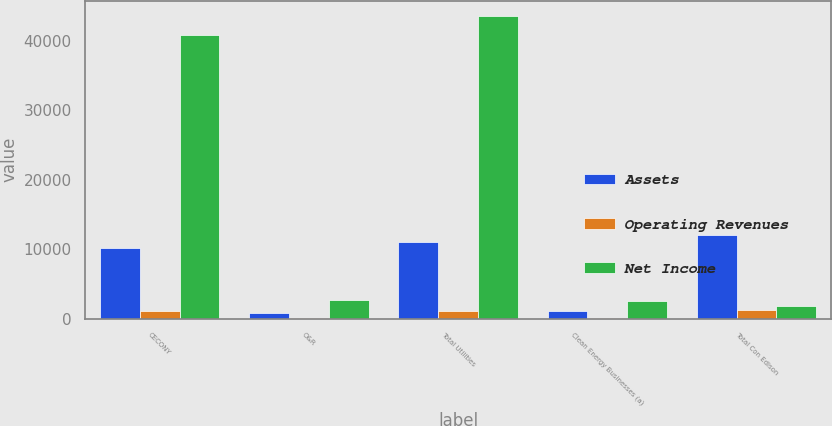Convert chart to OTSL. <chart><loc_0><loc_0><loc_500><loc_500><stacked_bar_chart><ecel><fcel>CECONY<fcel>O&R<fcel>Total Utilities<fcel>Clean Energy Businesses (a)<fcel>Total Con Edison<nl><fcel>Assets<fcel>10165<fcel>821<fcel>10986<fcel>1091<fcel>12075<nl><fcel>Operating Revenues<fcel>1056<fcel>59<fcel>1115<fcel>118<fcel>1245<nl><fcel>Net Income<fcel>40856<fcel>2758<fcel>43614<fcel>2551<fcel>1898<nl></chart> 